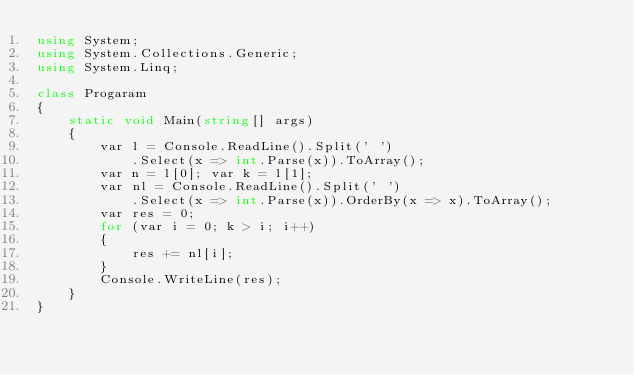<code> <loc_0><loc_0><loc_500><loc_500><_C#_>using System;
using System.Collections.Generic;
using System.Linq;

class Progaram
{
    static void Main(string[] args)
    {
        var l = Console.ReadLine().Split(' ')
            .Select(x => int.Parse(x)).ToArray();
        var n = l[0]; var k = l[1];
        var nl = Console.ReadLine().Split(' ')
            .Select(x => int.Parse(x)).OrderBy(x => x).ToArray();
        var res = 0;
        for (var i = 0; k > i; i++)
        {
            res += nl[i];
        }
        Console.WriteLine(res);
    }
}</code> 